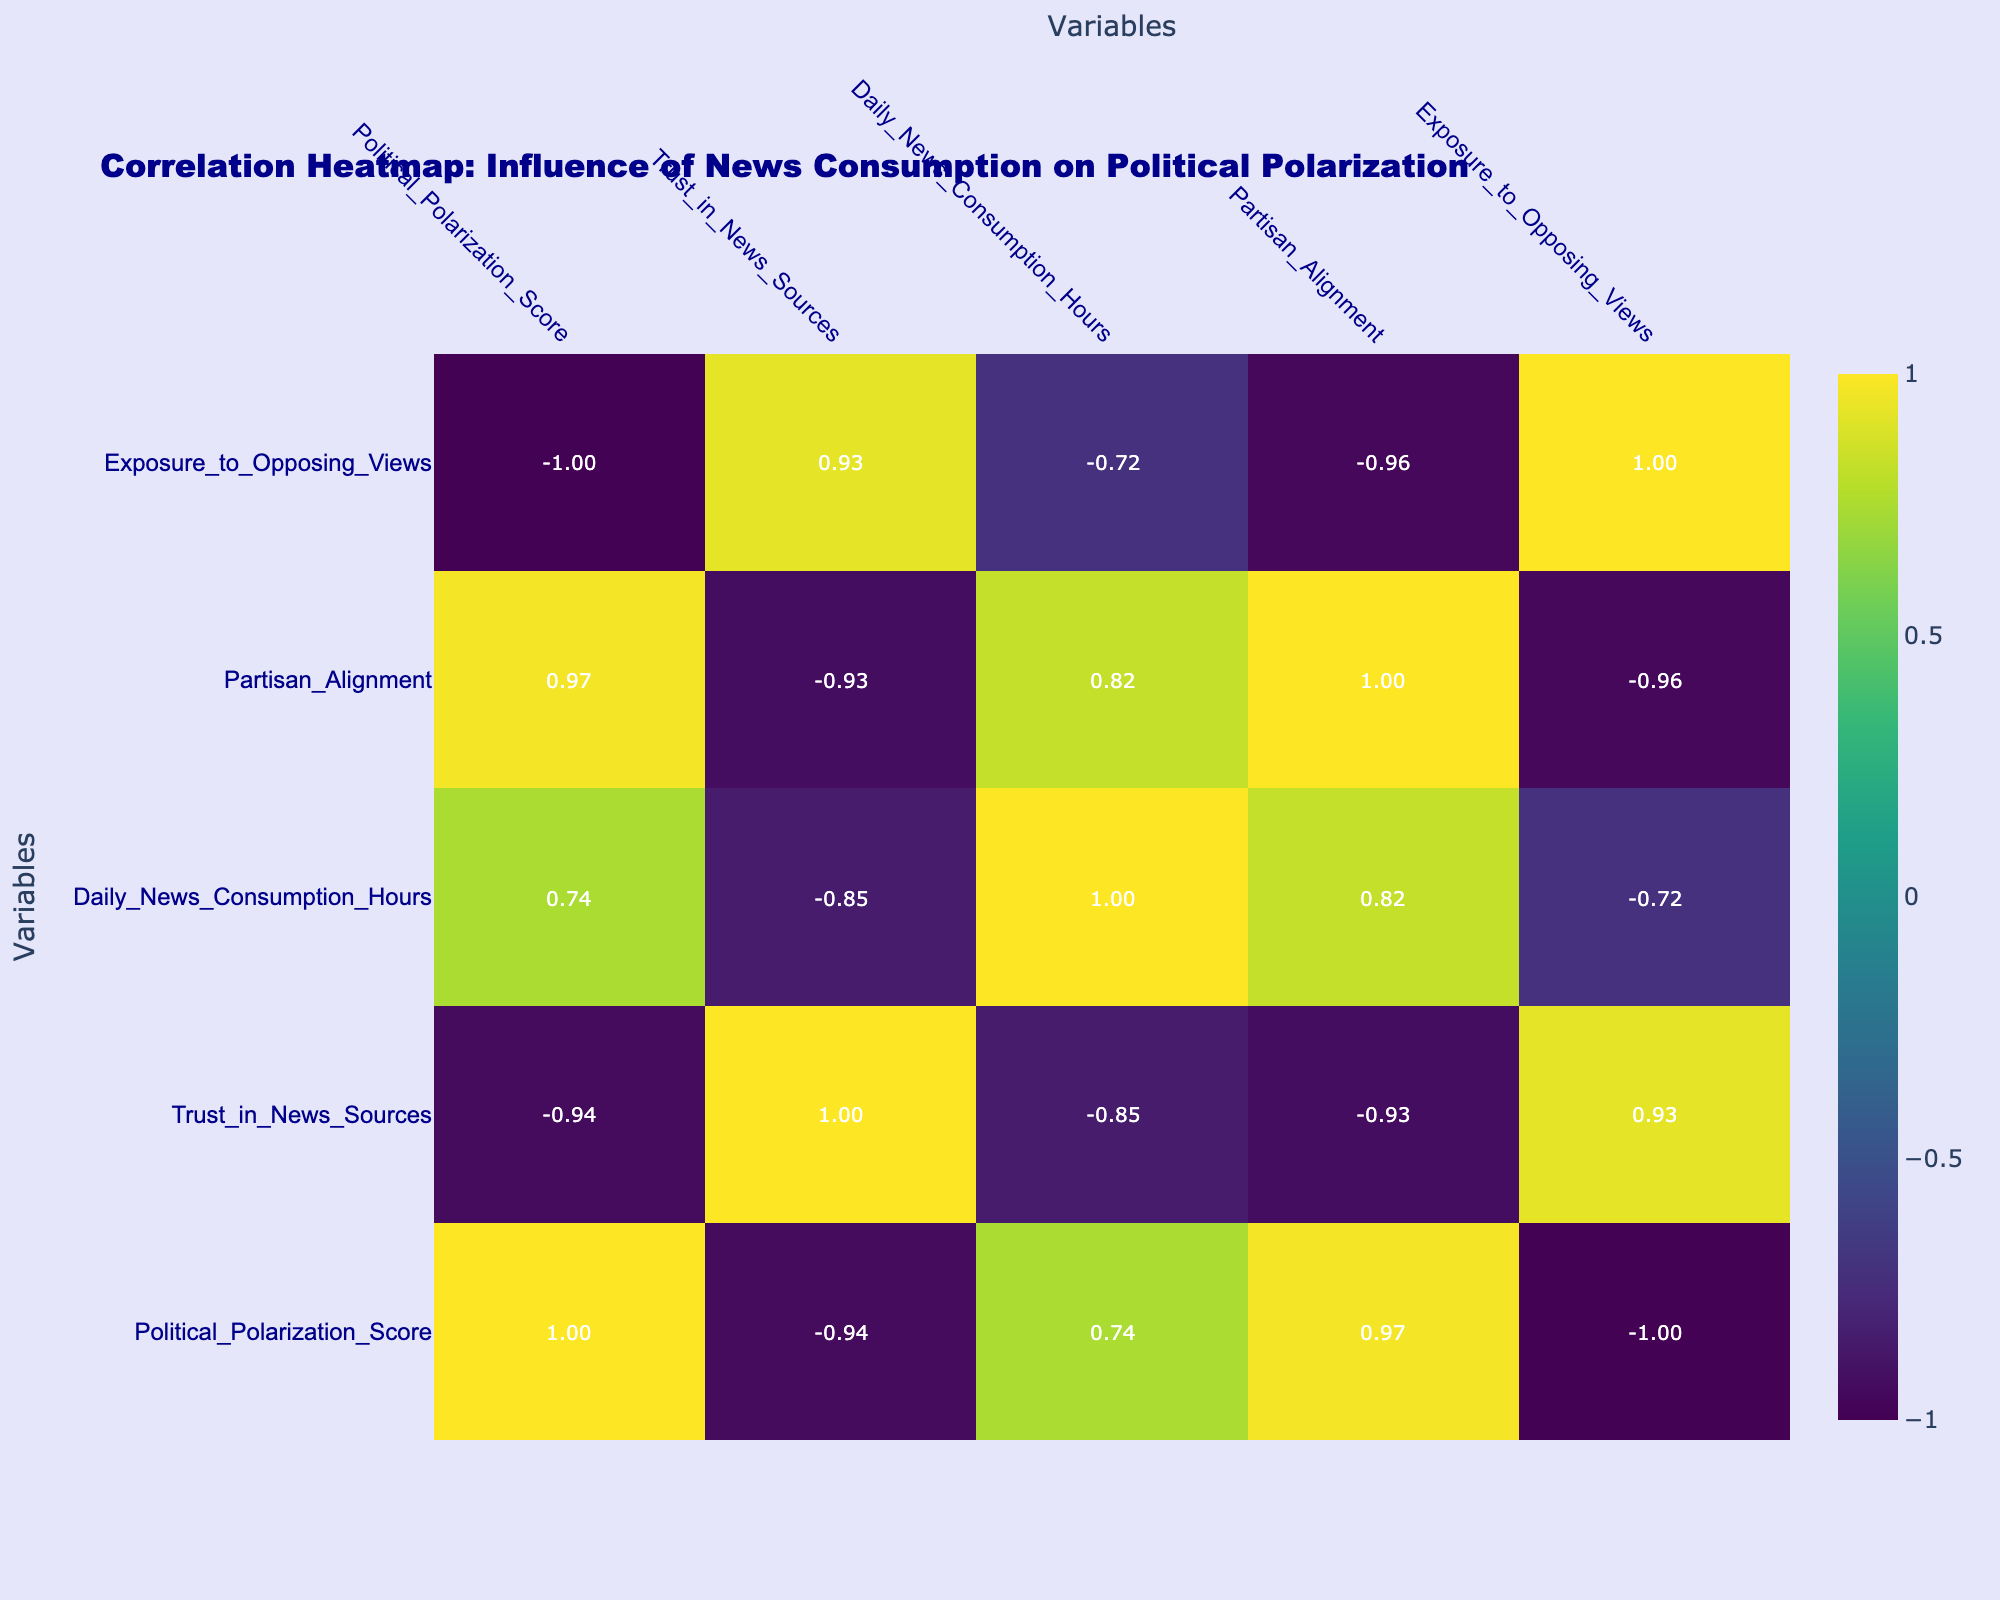What is the political polarization score for Cable News? The political polarization score for Cable News is directly listed in the table as 0.75.
Answer: 0.75 What is the trust in news sources score for Local Newspapers? The trust in news sources score for Local Newspapers can be found in the table, which shows it as 0.60.
Answer: 0.60 Which type of news consumption has the highest political polarization score? By comparing the scores in the table, Cable News has the highest political polarization score at 0.75 among all categories listed.
Answer: Cable News Is there a higher trust in news sources for Public Broadcasting compared to Alternative Media? The trust in news sources for Public Broadcasting is 0.70, while for Alternative Media, it is 0.30. Since 0.70 is greater than 0.30, the statement is true.
Answer: Yes What is the average daily news consumption hours across all news consumption types? To find the average, sum the daily news consumption hours: (2.5 + 3.0 + 1.0 + 1.5 + 2.0 + 1.8 + 0.8 + 2.5) = 14.1. Then divide by the number of types (8): 14.1 / 8 = 1.76.
Answer: 1.76 What is the correlation between Trust in News Sources and Exposure to Opposing Views? Looking at the correlation values in the table, the correlation between Trust in News Sources and Exposure to Opposing Views is approximately 0.15, indicating a weak positive correlation.
Answer: 0.15 Which news consumption type has the lowest exposure to opposing views? The table shows that Cable News has the lowest exposure to opposing views at 0.10.
Answer: Cable News Is there a strong correlation between Daily News Consumption Hours and Political Polarization Score? The correlation value between Daily News Consumption Hours and Political Polarization Score in the table is likely low. Specifically, since no strong value (close to 1 or -1) was listed between these two variables, the correlation is weak.
Answer: No What is the difference in political polarization score between Online Social Media and Print Newspapers? The political polarization score for Online Social Media is 0.65, and for Print Newspapers, it is 0.45. The difference is 0.65 - 0.45 = 0.20.
Answer: 0.20 